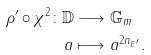<formula> <loc_0><loc_0><loc_500><loc_500>\rho ^ { \prime } \circ \chi ^ { 2 } \colon \mathbb { D } & \longrightarrow \mathbb { G } _ { m } \\ a & \longmapsto a ^ { 2 n _ { E ^ { \prime } } } .</formula> 